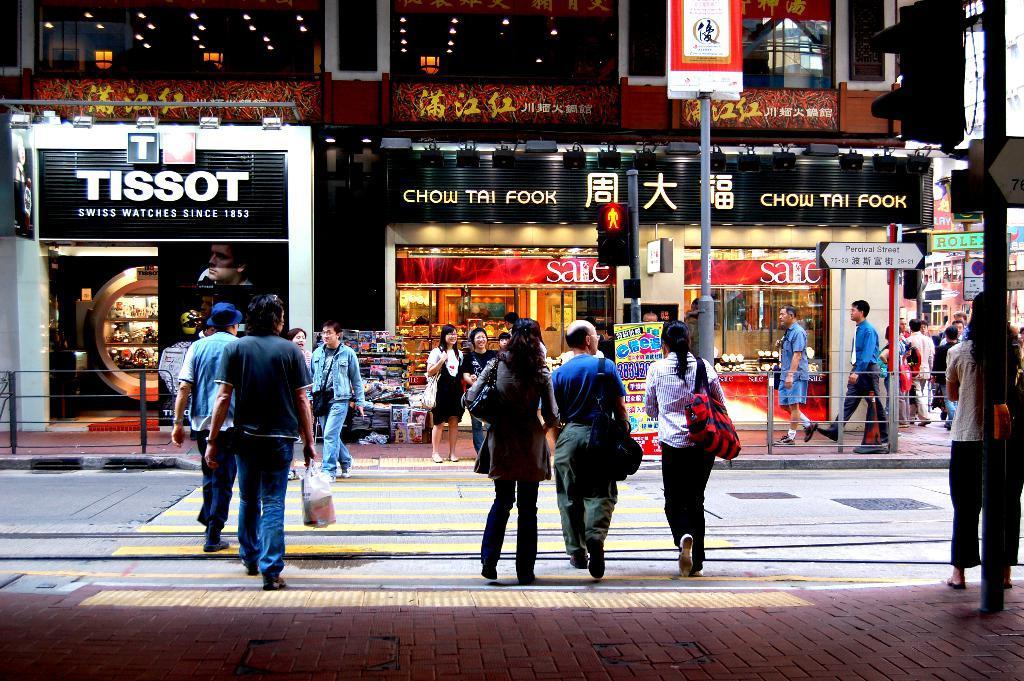Please provide a concise description of this image. In this picture there are people and we can see road, boards, traffic signals and poles. In the background of the image we can see building, stores, stall and boards. 